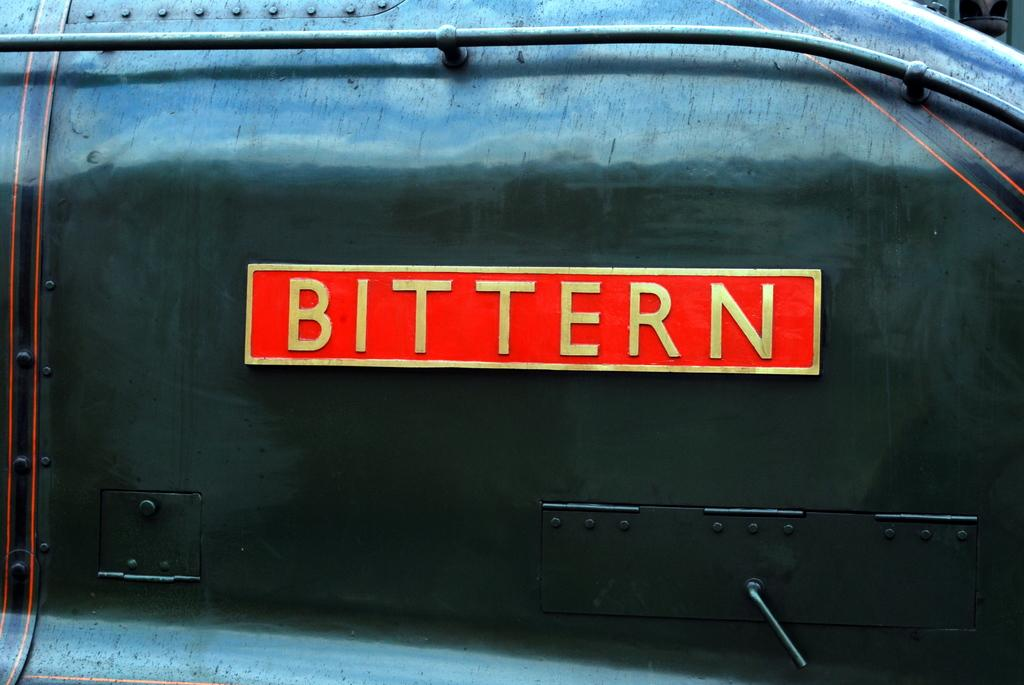<image>
Summarize the visual content of the image. The Bittern logo can be seen in gold lettering. 